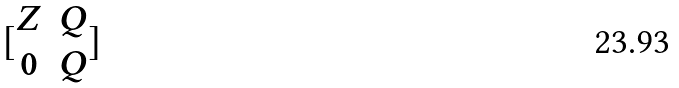Convert formula to latex. <formula><loc_0><loc_0><loc_500><loc_500>[ \begin{matrix} Z & Q \\ 0 & Q \end{matrix} ]</formula> 